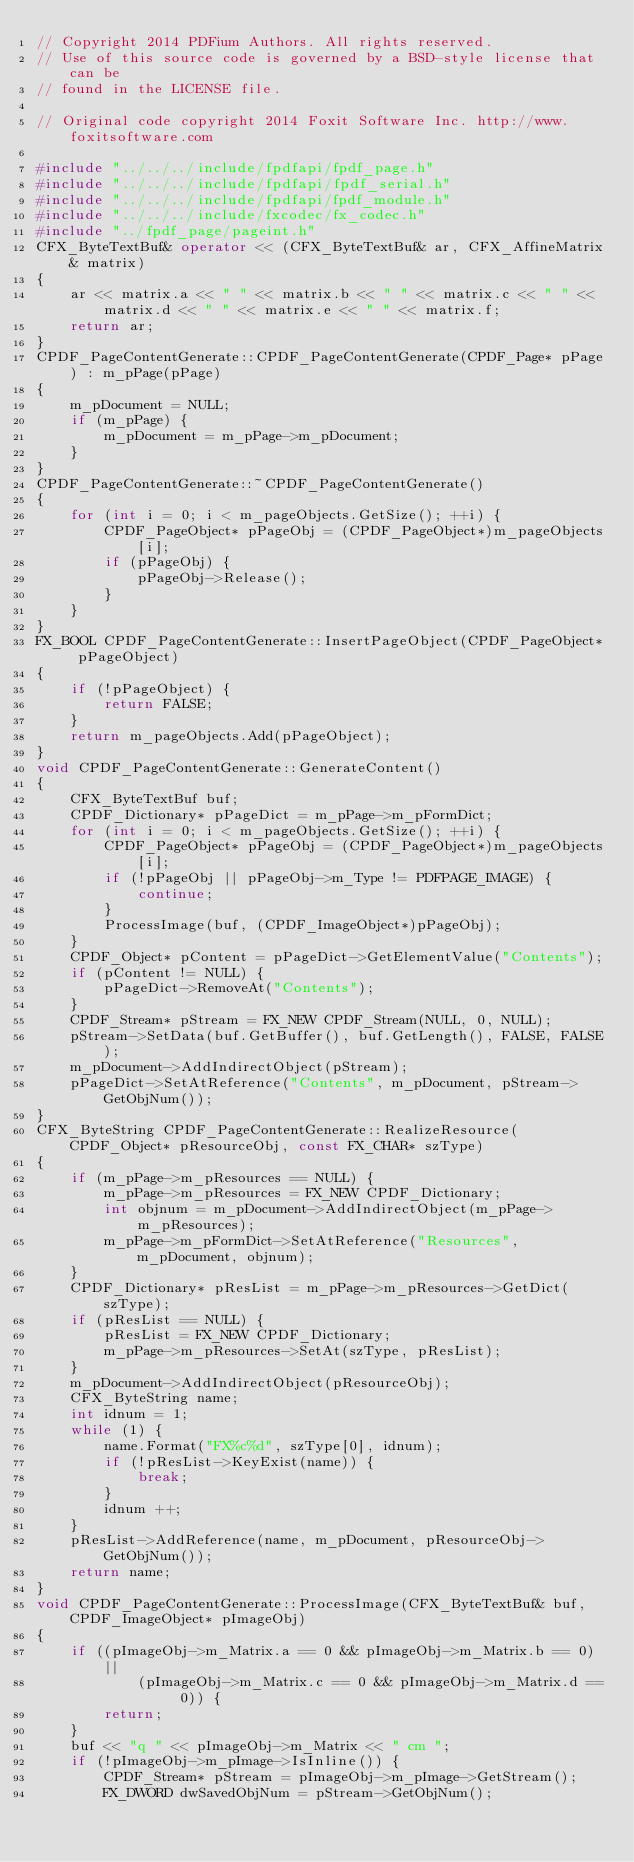<code> <loc_0><loc_0><loc_500><loc_500><_C++_>// Copyright 2014 PDFium Authors. All rights reserved.
// Use of this source code is governed by a BSD-style license that can be
// found in the LICENSE file.
 
// Original code copyright 2014 Foxit Software Inc. http://www.foxitsoftware.com

#include "../../../include/fpdfapi/fpdf_page.h"
#include "../../../include/fpdfapi/fpdf_serial.h"
#include "../../../include/fpdfapi/fpdf_module.h"
#include "../../../include/fxcodec/fx_codec.h"
#include "../fpdf_page/pageint.h"
CFX_ByteTextBuf& operator << (CFX_ByteTextBuf& ar, CFX_AffineMatrix& matrix)
{
    ar << matrix.a << " " << matrix.b << " " << matrix.c << " " << matrix.d << " " << matrix.e << " " << matrix.f;
    return ar;
}
CPDF_PageContentGenerate::CPDF_PageContentGenerate(CPDF_Page* pPage) : m_pPage(pPage)
{
    m_pDocument = NULL;
    if (m_pPage) {
        m_pDocument = m_pPage->m_pDocument;
    }
}
CPDF_PageContentGenerate::~CPDF_PageContentGenerate()
{
    for (int i = 0; i < m_pageObjects.GetSize(); ++i) {
        CPDF_PageObject* pPageObj = (CPDF_PageObject*)m_pageObjects[i];
        if (pPageObj) {
            pPageObj->Release();
        }
    }
}
FX_BOOL CPDF_PageContentGenerate::InsertPageObject(CPDF_PageObject* pPageObject)
{
    if (!pPageObject) {
        return FALSE;
    }
    return m_pageObjects.Add(pPageObject);
}
void CPDF_PageContentGenerate::GenerateContent()
{
    CFX_ByteTextBuf buf;
    CPDF_Dictionary* pPageDict = m_pPage->m_pFormDict;
    for (int i = 0; i < m_pageObjects.GetSize(); ++i) {
        CPDF_PageObject* pPageObj = (CPDF_PageObject*)m_pageObjects[i];
        if (!pPageObj || pPageObj->m_Type != PDFPAGE_IMAGE) {
            continue;
        }
        ProcessImage(buf, (CPDF_ImageObject*)pPageObj);
    }
    CPDF_Object* pContent = pPageDict->GetElementValue("Contents");
    if (pContent != NULL) {
        pPageDict->RemoveAt("Contents");
    }
    CPDF_Stream* pStream = FX_NEW CPDF_Stream(NULL, 0, NULL);
    pStream->SetData(buf.GetBuffer(), buf.GetLength(), FALSE, FALSE);
    m_pDocument->AddIndirectObject(pStream);
    pPageDict->SetAtReference("Contents", m_pDocument, pStream->GetObjNum());
}
CFX_ByteString CPDF_PageContentGenerate::RealizeResource(CPDF_Object* pResourceObj, const FX_CHAR* szType)
{
    if (m_pPage->m_pResources == NULL) {
        m_pPage->m_pResources = FX_NEW CPDF_Dictionary;
        int objnum = m_pDocument->AddIndirectObject(m_pPage->m_pResources);
        m_pPage->m_pFormDict->SetAtReference("Resources", m_pDocument, objnum);
    }
    CPDF_Dictionary* pResList = m_pPage->m_pResources->GetDict(szType);
    if (pResList == NULL) {
        pResList = FX_NEW CPDF_Dictionary;
        m_pPage->m_pResources->SetAt(szType, pResList);
    }
    m_pDocument->AddIndirectObject(pResourceObj);
    CFX_ByteString name;
    int idnum = 1;
    while (1) {
        name.Format("FX%c%d", szType[0], idnum);
        if (!pResList->KeyExist(name)) {
            break;
        }
        idnum ++;
    }
    pResList->AddReference(name, m_pDocument, pResourceObj->GetObjNum());
    return name;
}
void CPDF_PageContentGenerate::ProcessImage(CFX_ByteTextBuf& buf, CPDF_ImageObject* pImageObj)
{
    if ((pImageObj->m_Matrix.a == 0 && pImageObj->m_Matrix.b == 0) ||
            (pImageObj->m_Matrix.c == 0 && pImageObj->m_Matrix.d == 0)) {
        return;
    }
    buf << "q " << pImageObj->m_Matrix << " cm ";
    if (!pImageObj->m_pImage->IsInline()) {
        CPDF_Stream* pStream = pImageObj->m_pImage->GetStream();
        FX_DWORD dwSavedObjNum = pStream->GetObjNum();</code> 